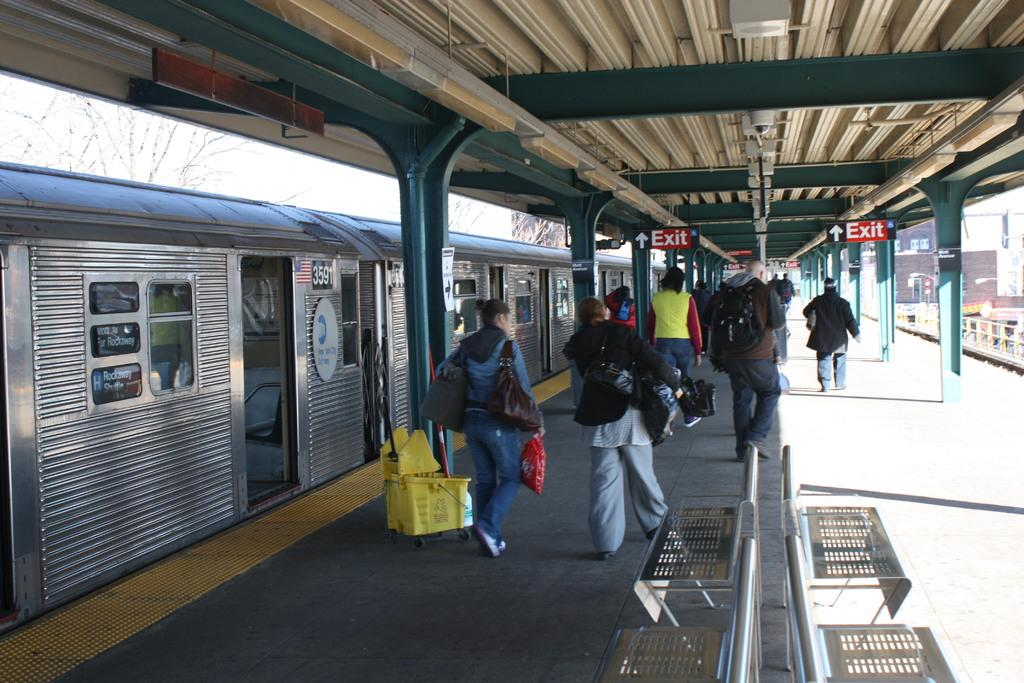How many people are present in the image? There are many people in the image. What are the people doing in the image? The people are walking on a platform in the image. What are the people holding in their hands? The people are holding objects in their hands in the image. What can be seen in the background of the image? There is a train in the image. What type of brush is being used by the people in the image? There is no brush visible in the image; the people are holding objects, but they are not specified as brushes. 